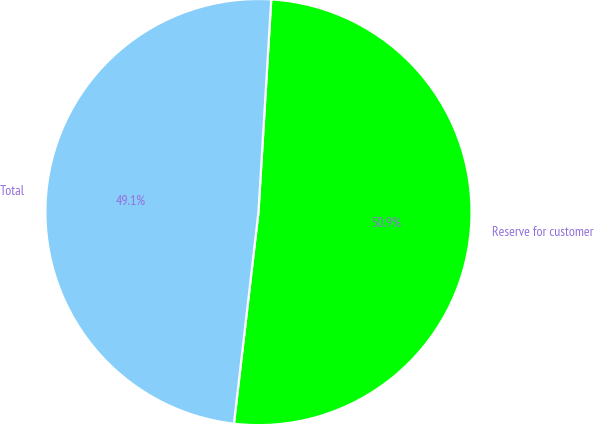Convert chart. <chart><loc_0><loc_0><loc_500><loc_500><pie_chart><fcel>Reserve for customer<fcel>Total<nl><fcel>50.88%<fcel>49.12%<nl></chart> 